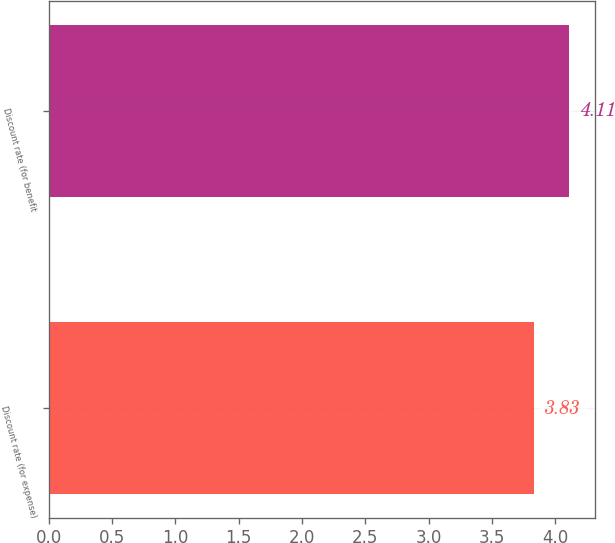<chart> <loc_0><loc_0><loc_500><loc_500><bar_chart><fcel>Discount rate (for expense)<fcel>Discount rate (for benefit<nl><fcel>3.83<fcel>4.11<nl></chart> 